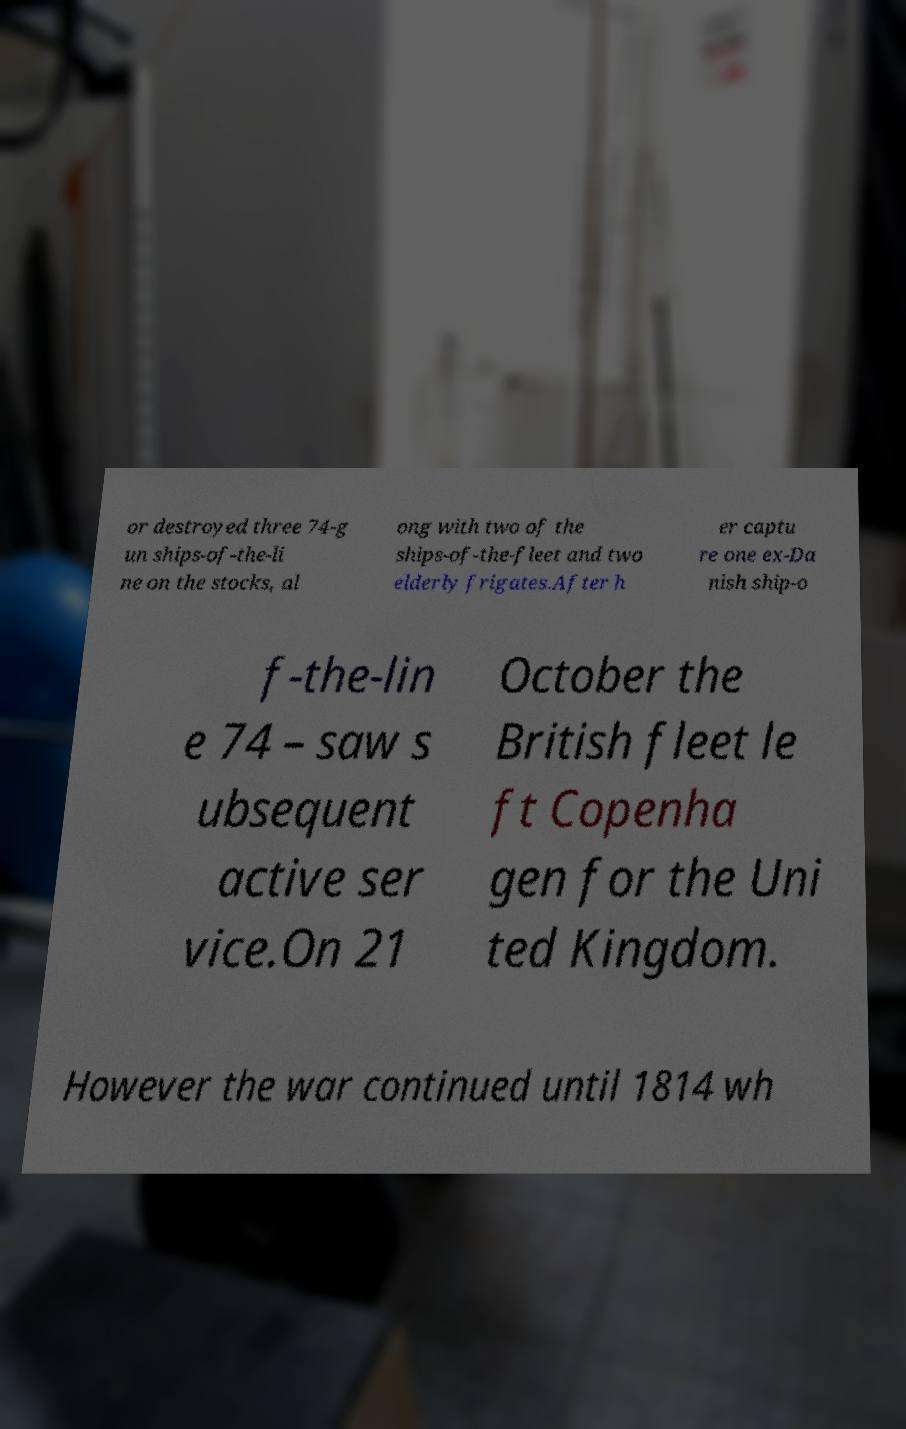Can you accurately transcribe the text from the provided image for me? or destroyed three 74-g un ships-of-the-li ne on the stocks, al ong with two of the ships-of-the-fleet and two elderly frigates.After h er captu re one ex-Da nish ship-o f-the-lin e 74 – saw s ubsequent active ser vice.On 21 October the British fleet le ft Copenha gen for the Uni ted Kingdom. However the war continued until 1814 wh 